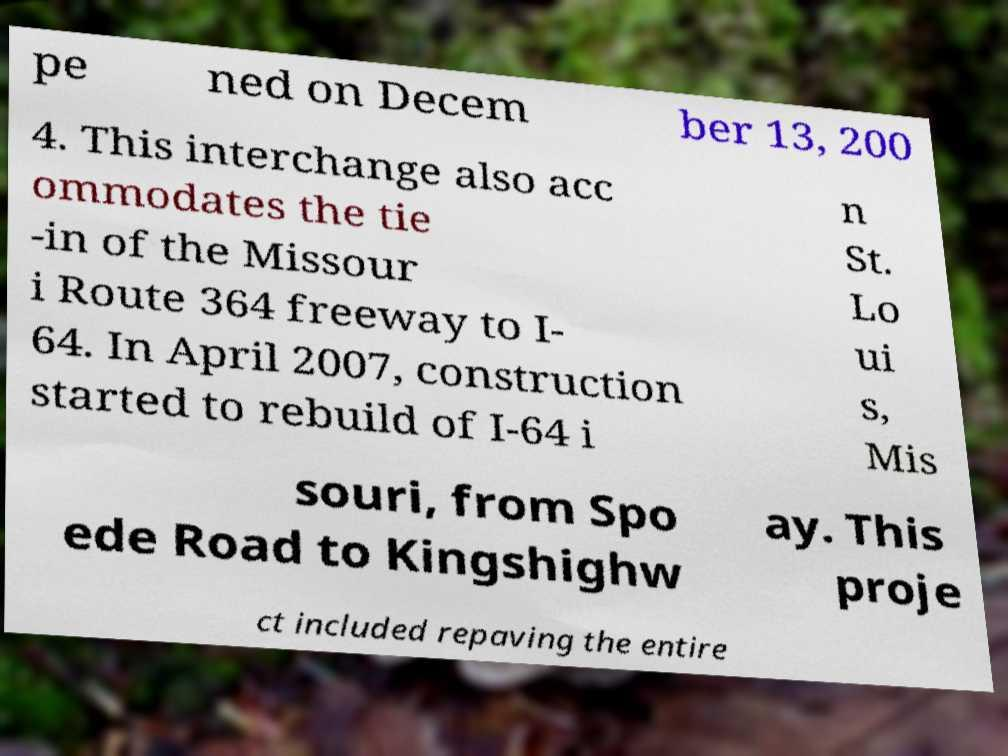Could you extract and type out the text from this image? pe ned on Decem ber 13, 200 4. This interchange also acc ommodates the tie -in of the Missour i Route 364 freeway to I- 64. In April 2007, construction started to rebuild of I-64 i n St. Lo ui s, Mis souri, from Spo ede Road to Kingshighw ay. This proje ct included repaving the entire 